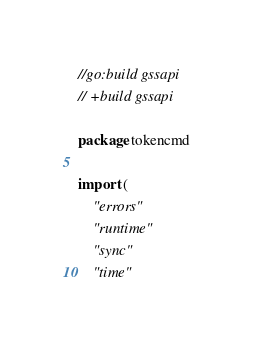<code> <loc_0><loc_0><loc_500><loc_500><_Go_>//go:build gssapi
// +build gssapi

package tokencmd

import (
	"errors"
	"runtime"
	"sync"
	"time"
</code> 